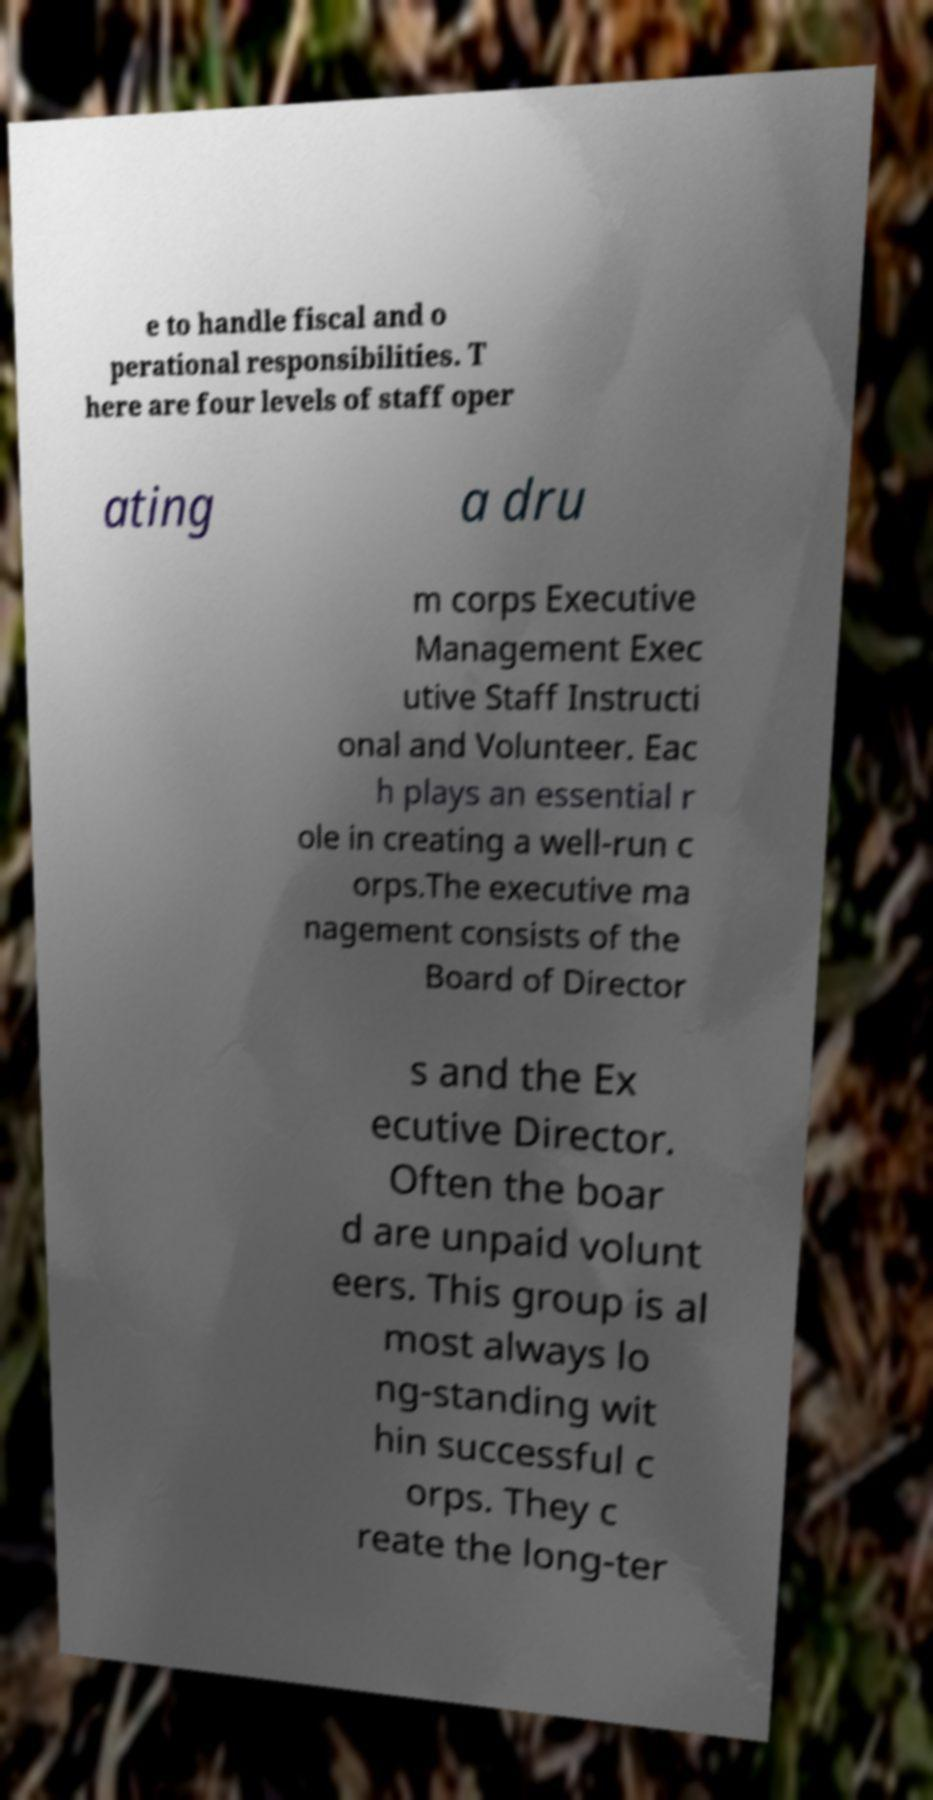There's text embedded in this image that I need extracted. Can you transcribe it verbatim? e to handle fiscal and o perational responsibilities. T here are four levels of staff oper ating a dru m corps Executive Management Exec utive Staff Instructi onal and Volunteer. Eac h plays an essential r ole in creating a well-run c orps.The executive ma nagement consists of the Board of Director s and the Ex ecutive Director. Often the boar d are unpaid volunt eers. This group is al most always lo ng-standing wit hin successful c orps. They c reate the long-ter 